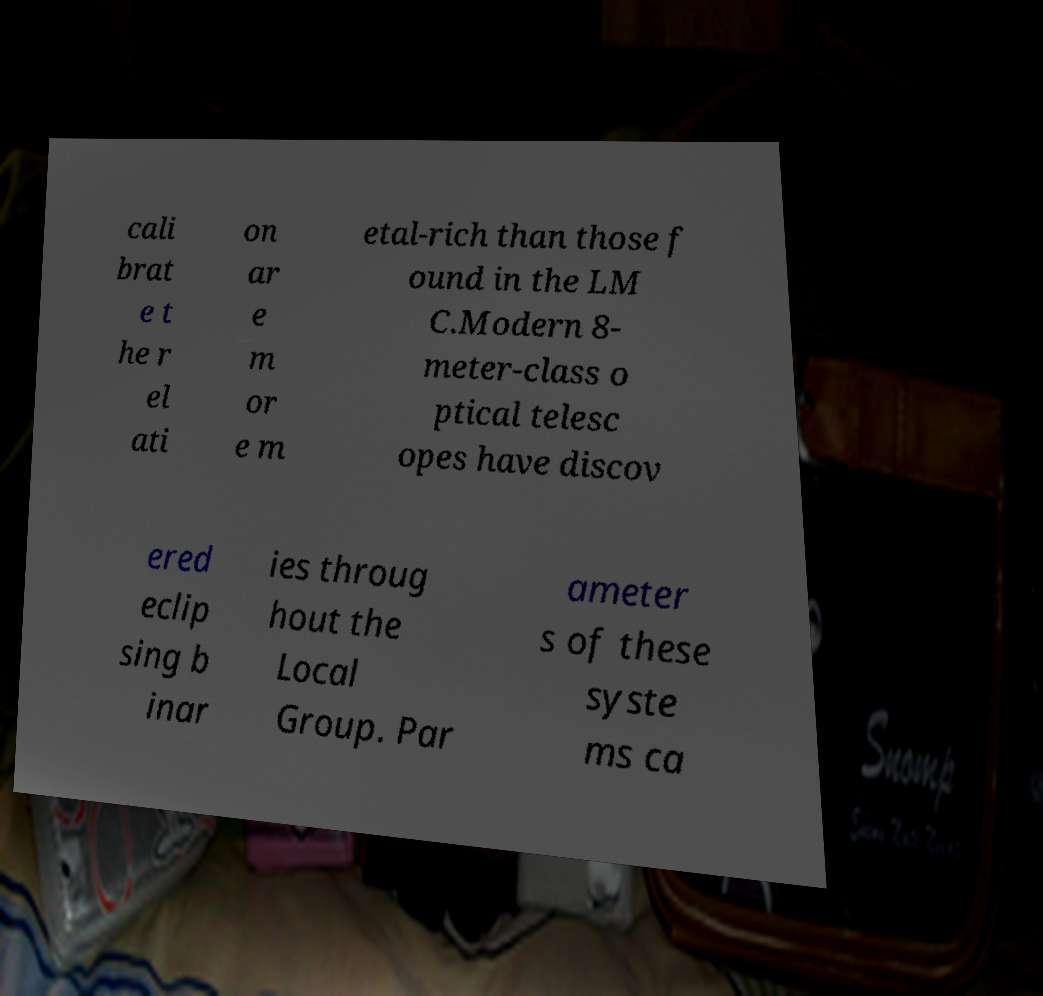What messages or text are displayed in this image? I need them in a readable, typed format. cali brat e t he r el ati on ar e m or e m etal-rich than those f ound in the LM C.Modern 8- meter-class o ptical telesc opes have discov ered eclip sing b inar ies throug hout the Local Group. Par ameter s of these syste ms ca 